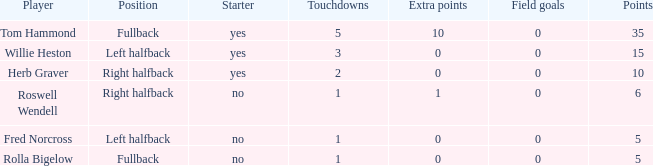What is the smallest number of field goals for a player with 3 touchdowns? 0.0. 